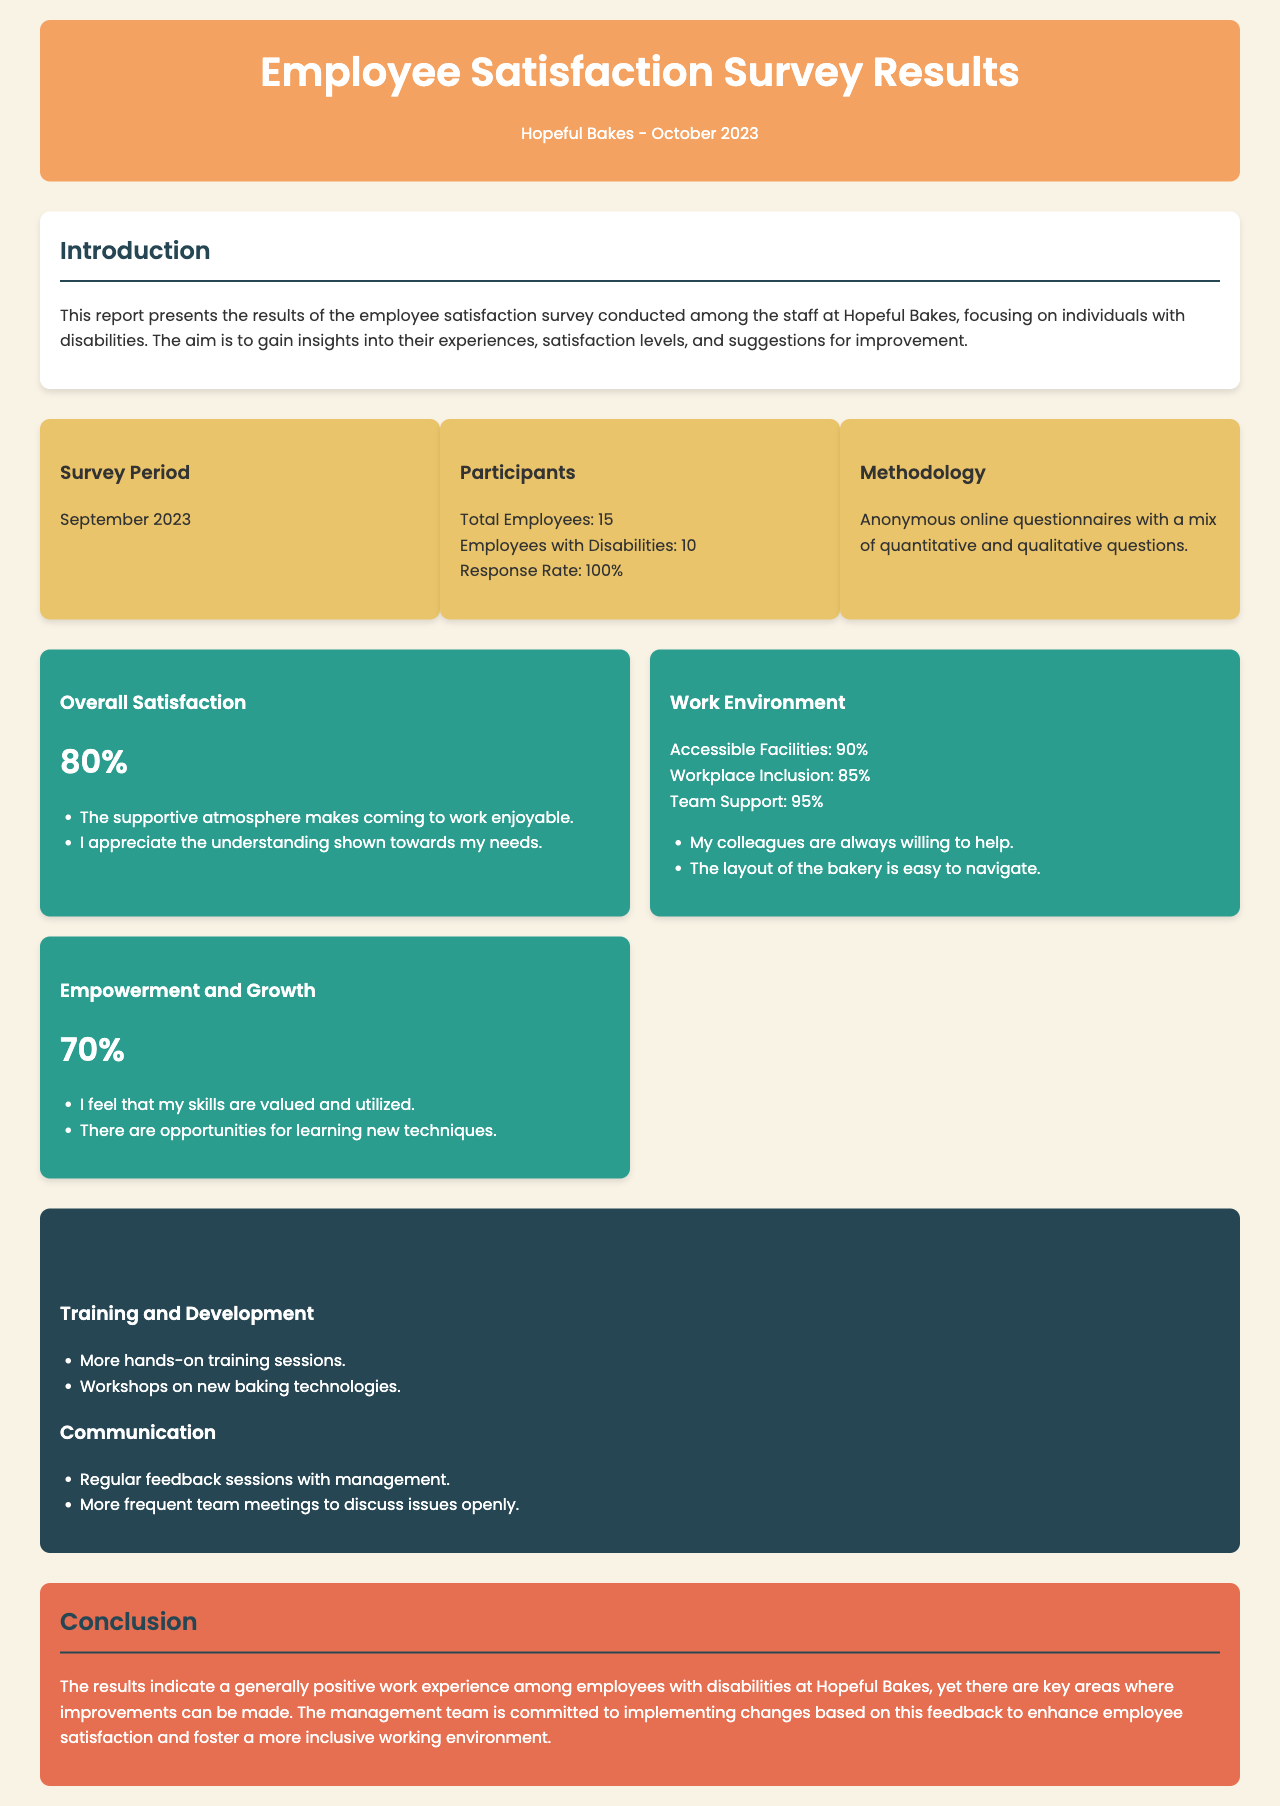what was the survey period? The survey period is specified as September 2023 in the document.
Answer: September 2023 how many employees participated in the survey? The document states that there were a total of 15 employees, including employees with disabilities.
Answer: 15 what percentage of employees with disabilities reported overall satisfaction? The document indicates that the overall satisfaction rate is 80%.
Answer: 80% what percentage of respondents feel supported by their colleagues? The document highlights that 95% of respondents feel team support in the workplace.
Answer: 95% what are two suggested areas for improvement mentioned in the document? The document lists "Training and Development" and "Communication" as areas needing improvement.
Answer: Training and Development, Communication what is the rate of accessible facilities according to the survey? The survey results reflect that 90% of respondents believe the facilities are accessible.
Answer: 90% how do employees feel about their skills being utilized? The document reports that 70% of respondents feel their skills are valued and utilized.
Answer: 70% what commitment does the management team express in the conclusion? The conclusion states that the management team is committed to implementing changes based on feedback.
Answer: Committed to implementing changes 